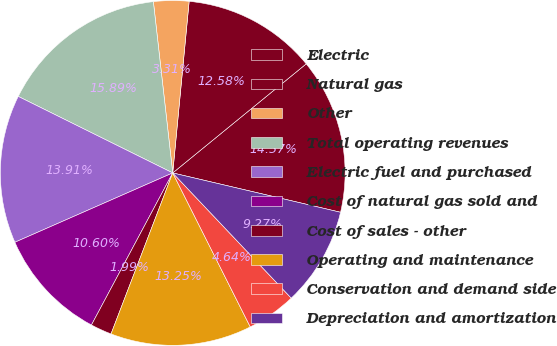Convert chart. <chart><loc_0><loc_0><loc_500><loc_500><pie_chart><fcel>Electric<fcel>Natural gas<fcel>Other<fcel>Total operating revenues<fcel>Electric fuel and purchased<fcel>Cost of natural gas sold and<fcel>Cost of sales - other<fcel>Operating and maintenance<fcel>Conservation and demand side<fcel>Depreciation and amortization<nl><fcel>14.57%<fcel>12.58%<fcel>3.31%<fcel>15.89%<fcel>13.91%<fcel>10.6%<fcel>1.99%<fcel>13.25%<fcel>4.64%<fcel>9.27%<nl></chart> 